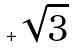<formula> <loc_0><loc_0><loc_500><loc_500>+ \sqrt { 3 }</formula> 